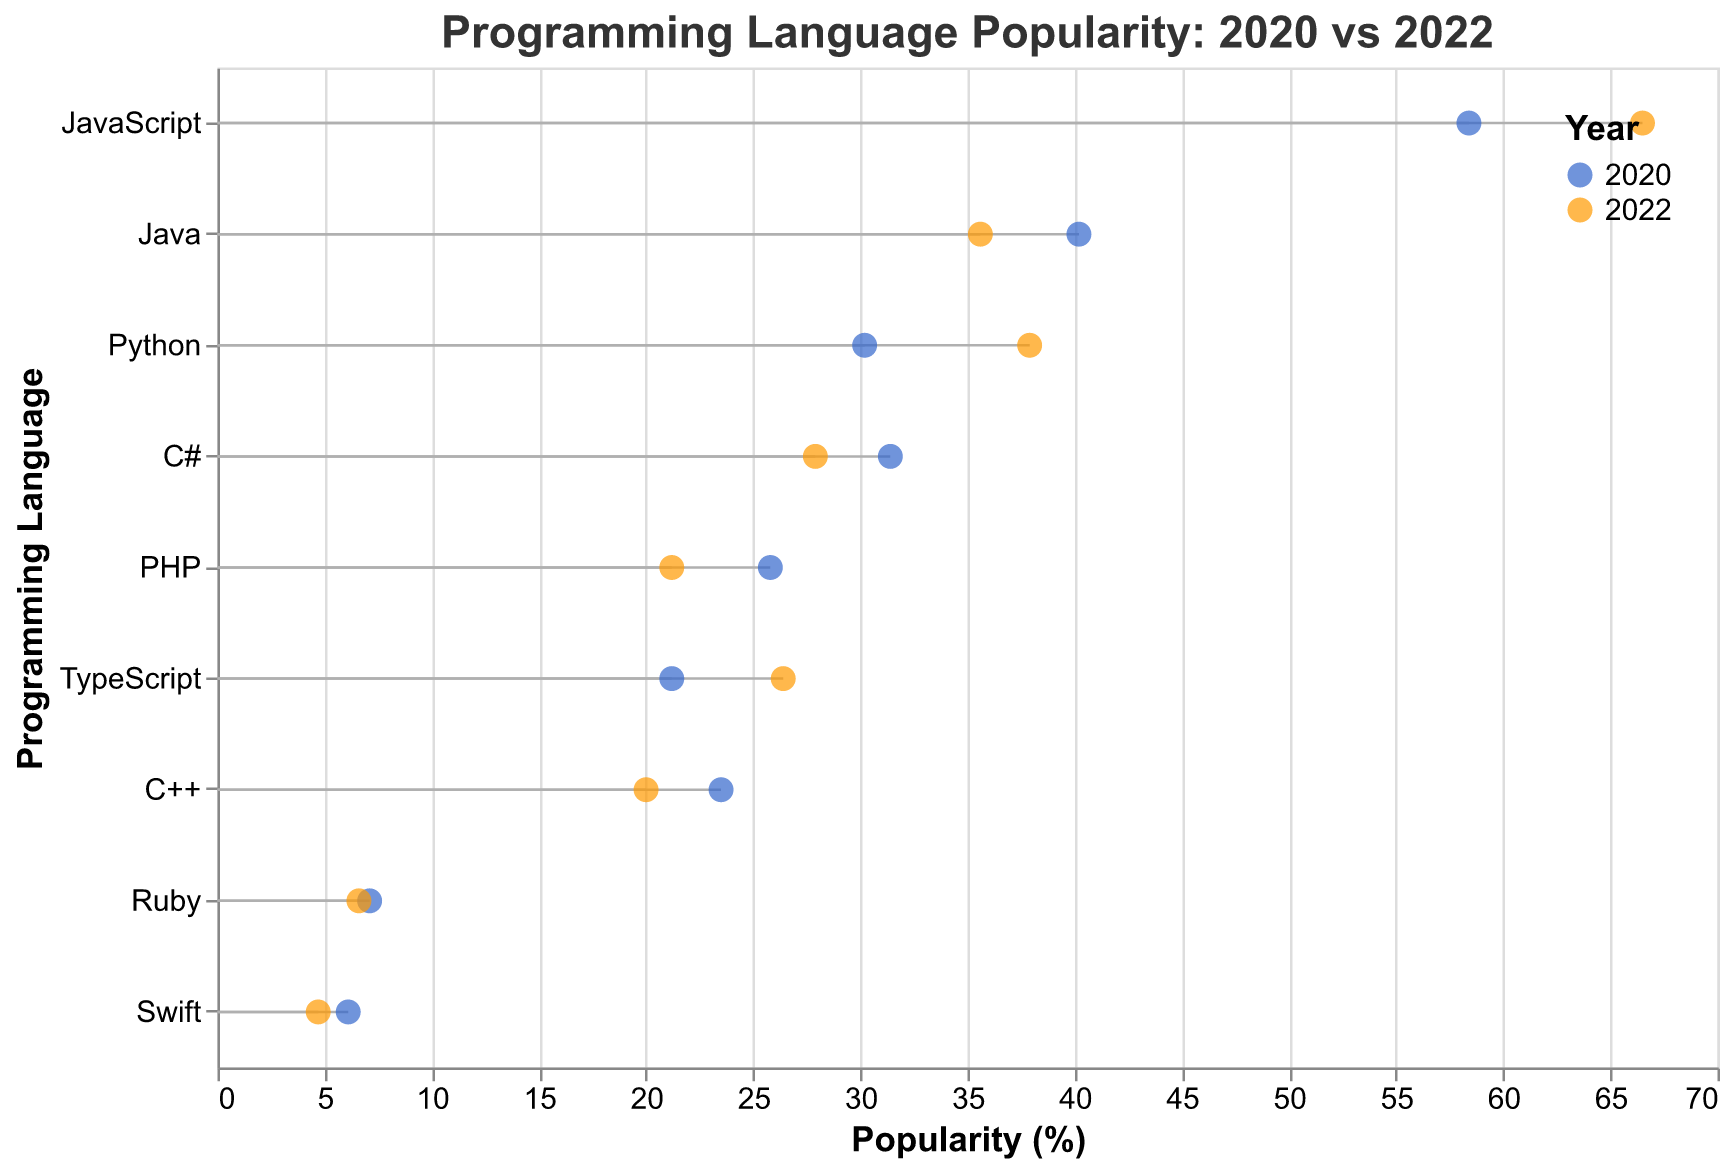How many programming languages are compared in the plot? Count the unique programming languages listed on the y-axis. There are 10 languages: Python, JavaScript, Java, C#, PHP, TypeScript, C++, Ruby, Swift.
Answer: 10 Which programming language was the most popular in 2022? Look for the programming language with the highest popularity percentage for the year 2022. JavaScript has the highest value at 66.5%.
Answer: JavaScript What is the difference in popularity percentage of Python between 2020 and 2022? Subtract the popularity percentage of Python in 2020 from its popularity percentage in 2022 (37.9% - 30.2%).
Answer: 7.7 Which programming language showed a decline in popularity from 2020 to 2022? Identify the programming languages whose popularity percentages decreased from 2020 to 2022: Java, C#, PHP, C++, Ruby, Swift.
Answer: Java, C#, PHP, C++, Ruby, Swift What is the average popularity percentage of JavaScript over 2020 and 2022? Add the popularity percentages of JavaScript for 2020 and 2022, then divide by 2 ((58.4 + 66.5) / 2).
Answer: 62.45 Which year is represented by the blue color in the plot? According to the legend in the figure, the blue color represents the year 2020.
Answer: 2020 Between TypeScript and C++, which language had a higher increase or smaller decrease in popularity? TypeScript increased from 21.2% to 26.4% (difference = +5.2), while C++ decreased from 23.5% to 20.0% (difference = -3.5).
Answer: TypeScript What was the popularity percentage of Ruby in 2022? Look at the point corresponding to Ruby for the year 2022. The value is 6.6%.
Answer: 6.6 Which programming language had a higher popularity in 2020: C# or PHP? Compare the popularity percentages for C# and PHP in 2020. C# has 31.4% and PHP has 25.8%.
Answer: C# What is the overall trend for Swift between 2020 and 2022? Look at the positions of Swift in 2020 and 2022. The popularity decreased from 6.1% to 4.7%.
Answer: Decrease 